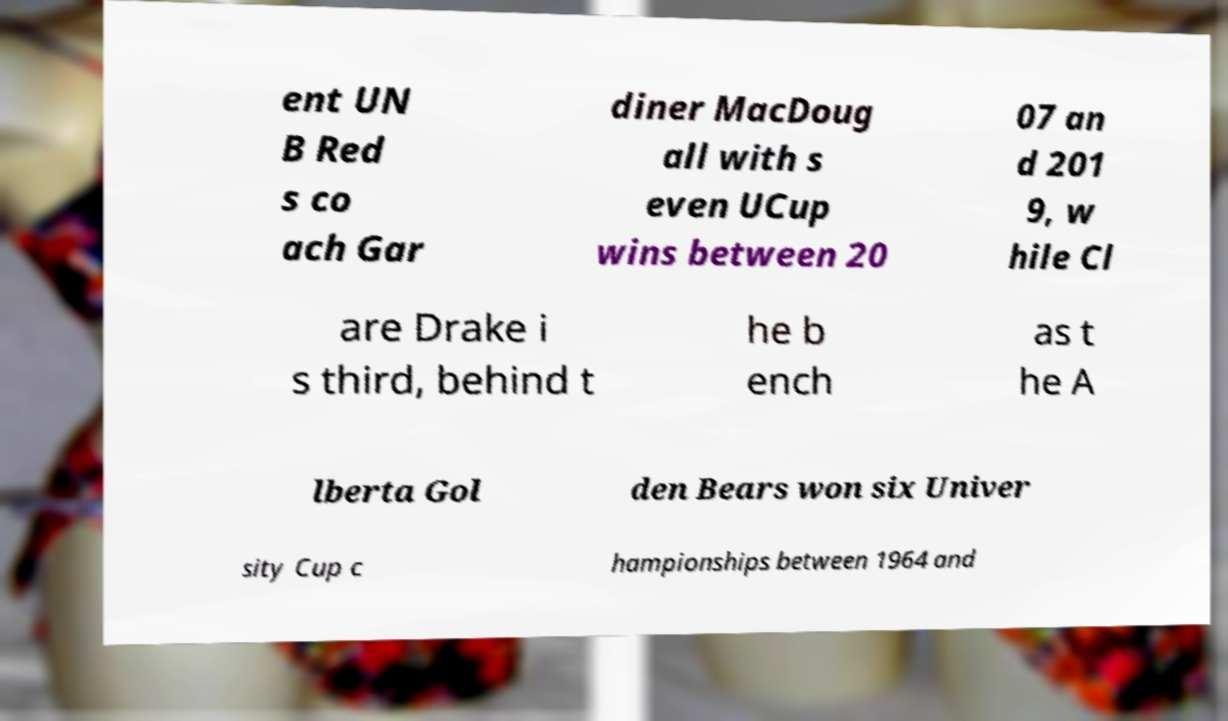Please identify and transcribe the text found in this image. ent UN B Red s co ach Gar diner MacDoug all with s even UCup wins between 20 07 an d 201 9, w hile Cl are Drake i s third, behind t he b ench as t he A lberta Gol den Bears won six Univer sity Cup c hampionships between 1964 and 